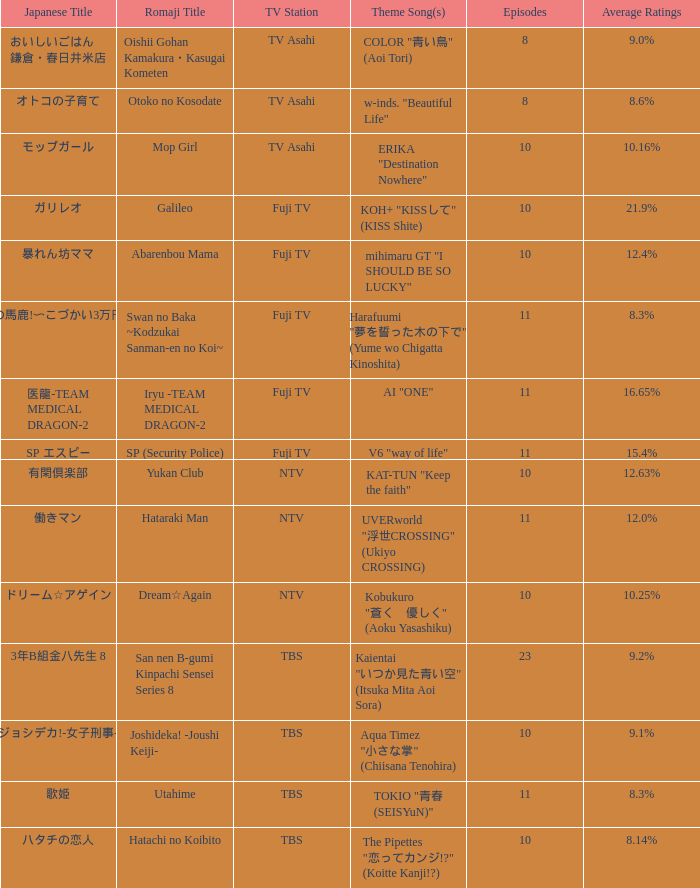What is the Theme Song of Iryu -Team Medical Dragon-2? AI "ONE". 